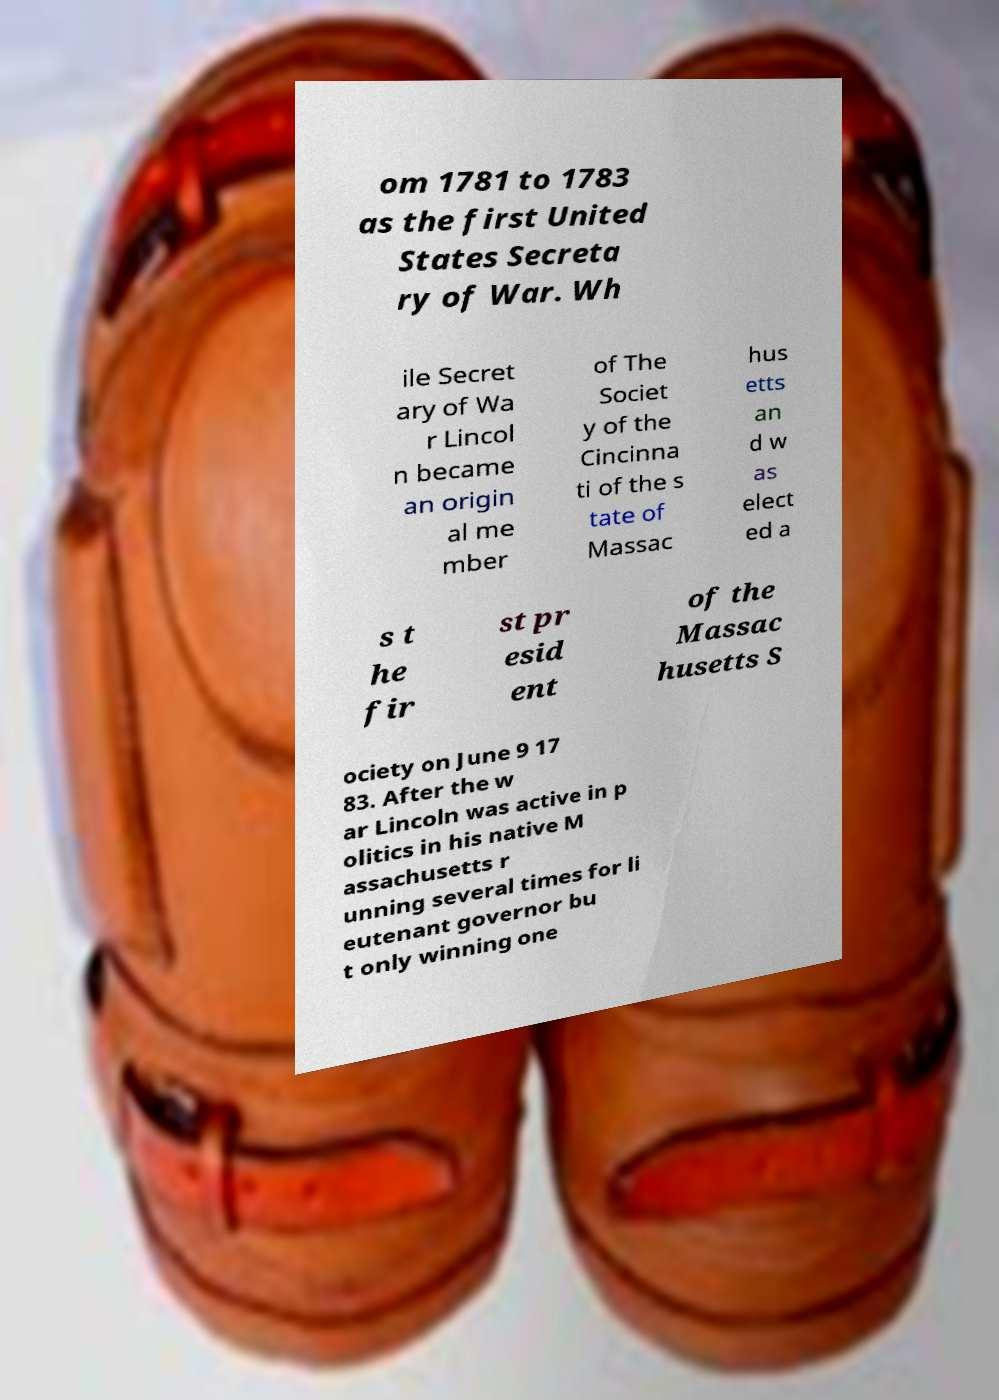Could you assist in decoding the text presented in this image and type it out clearly? om 1781 to 1783 as the first United States Secreta ry of War. Wh ile Secret ary of Wa r Lincol n became an origin al me mber of The Societ y of the Cincinna ti of the s tate of Massac hus etts an d w as elect ed a s t he fir st pr esid ent of the Massac husetts S ociety on June 9 17 83. After the w ar Lincoln was active in p olitics in his native M assachusetts r unning several times for li eutenant governor bu t only winning one 